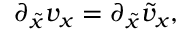<formula> <loc_0><loc_0><loc_500><loc_500>\begin{array} { r } { \partial _ { \tilde { x } } v _ { x } = \partial _ { \tilde { x } } \tilde { v } _ { x } , } \end{array}</formula> 